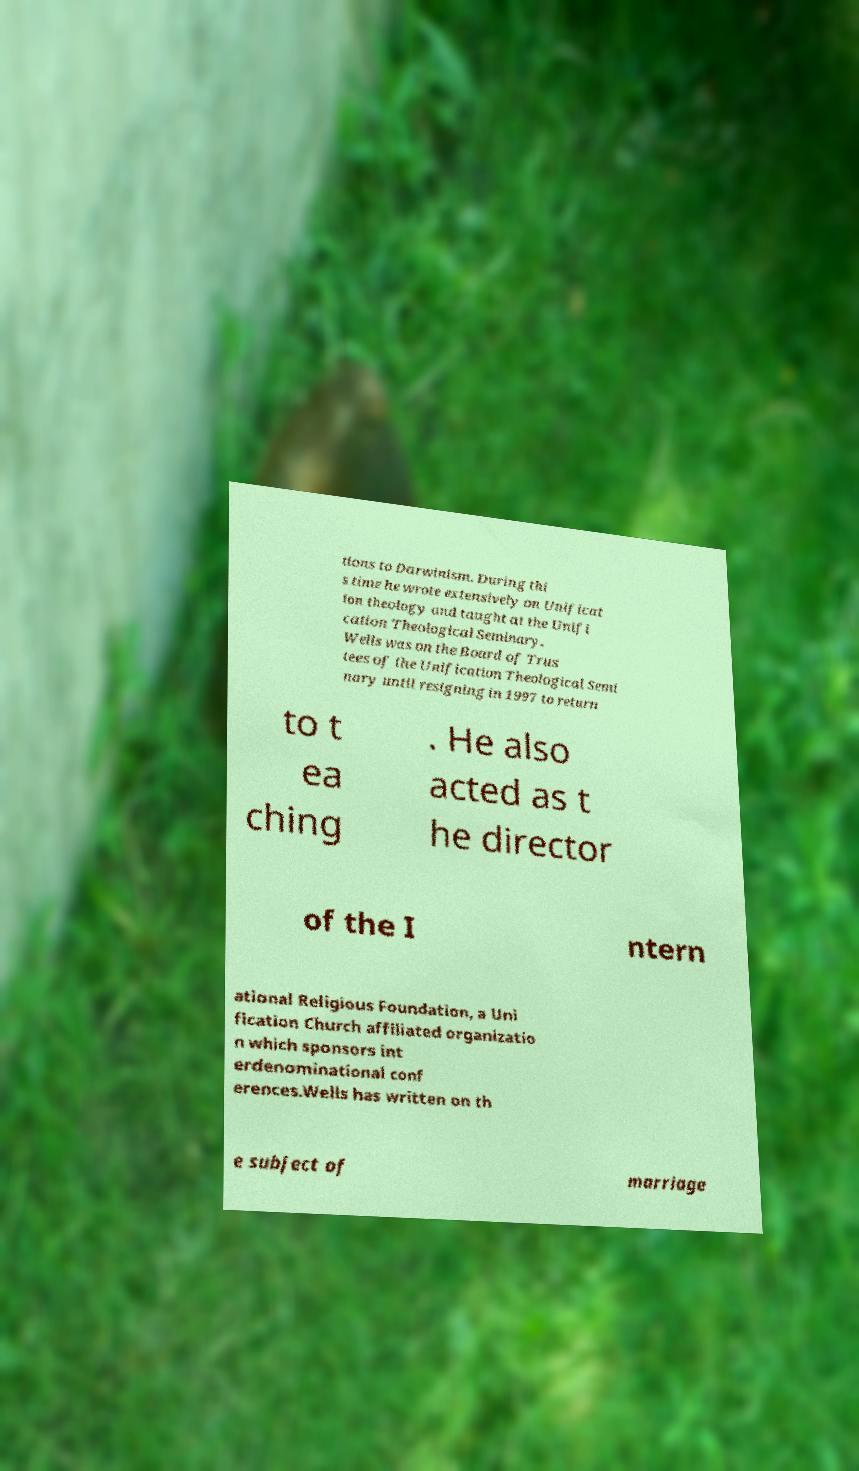What messages or text are displayed in this image? I need them in a readable, typed format. tions to Darwinism. During thi s time he wrote extensively on Unificat ion theology and taught at the Unifi cation Theological Seminary. Wells was on the Board of Trus tees of the Unification Theological Semi nary until resigning in 1997 to return to t ea ching . He also acted as t he director of the I ntern ational Religious Foundation, a Uni fication Church affiliated organizatio n which sponsors int erdenominational conf erences.Wells has written on th e subject of marriage 